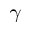Convert formula to latex. <formula><loc_0><loc_0><loc_500><loc_500>\gamma</formula> 